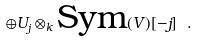Convert formula to latex. <formula><loc_0><loc_0><loc_500><loc_500>\oplus U _ { j } \otimes _ { k } \text {Sym} ( V ) [ - j ] \ .</formula> 